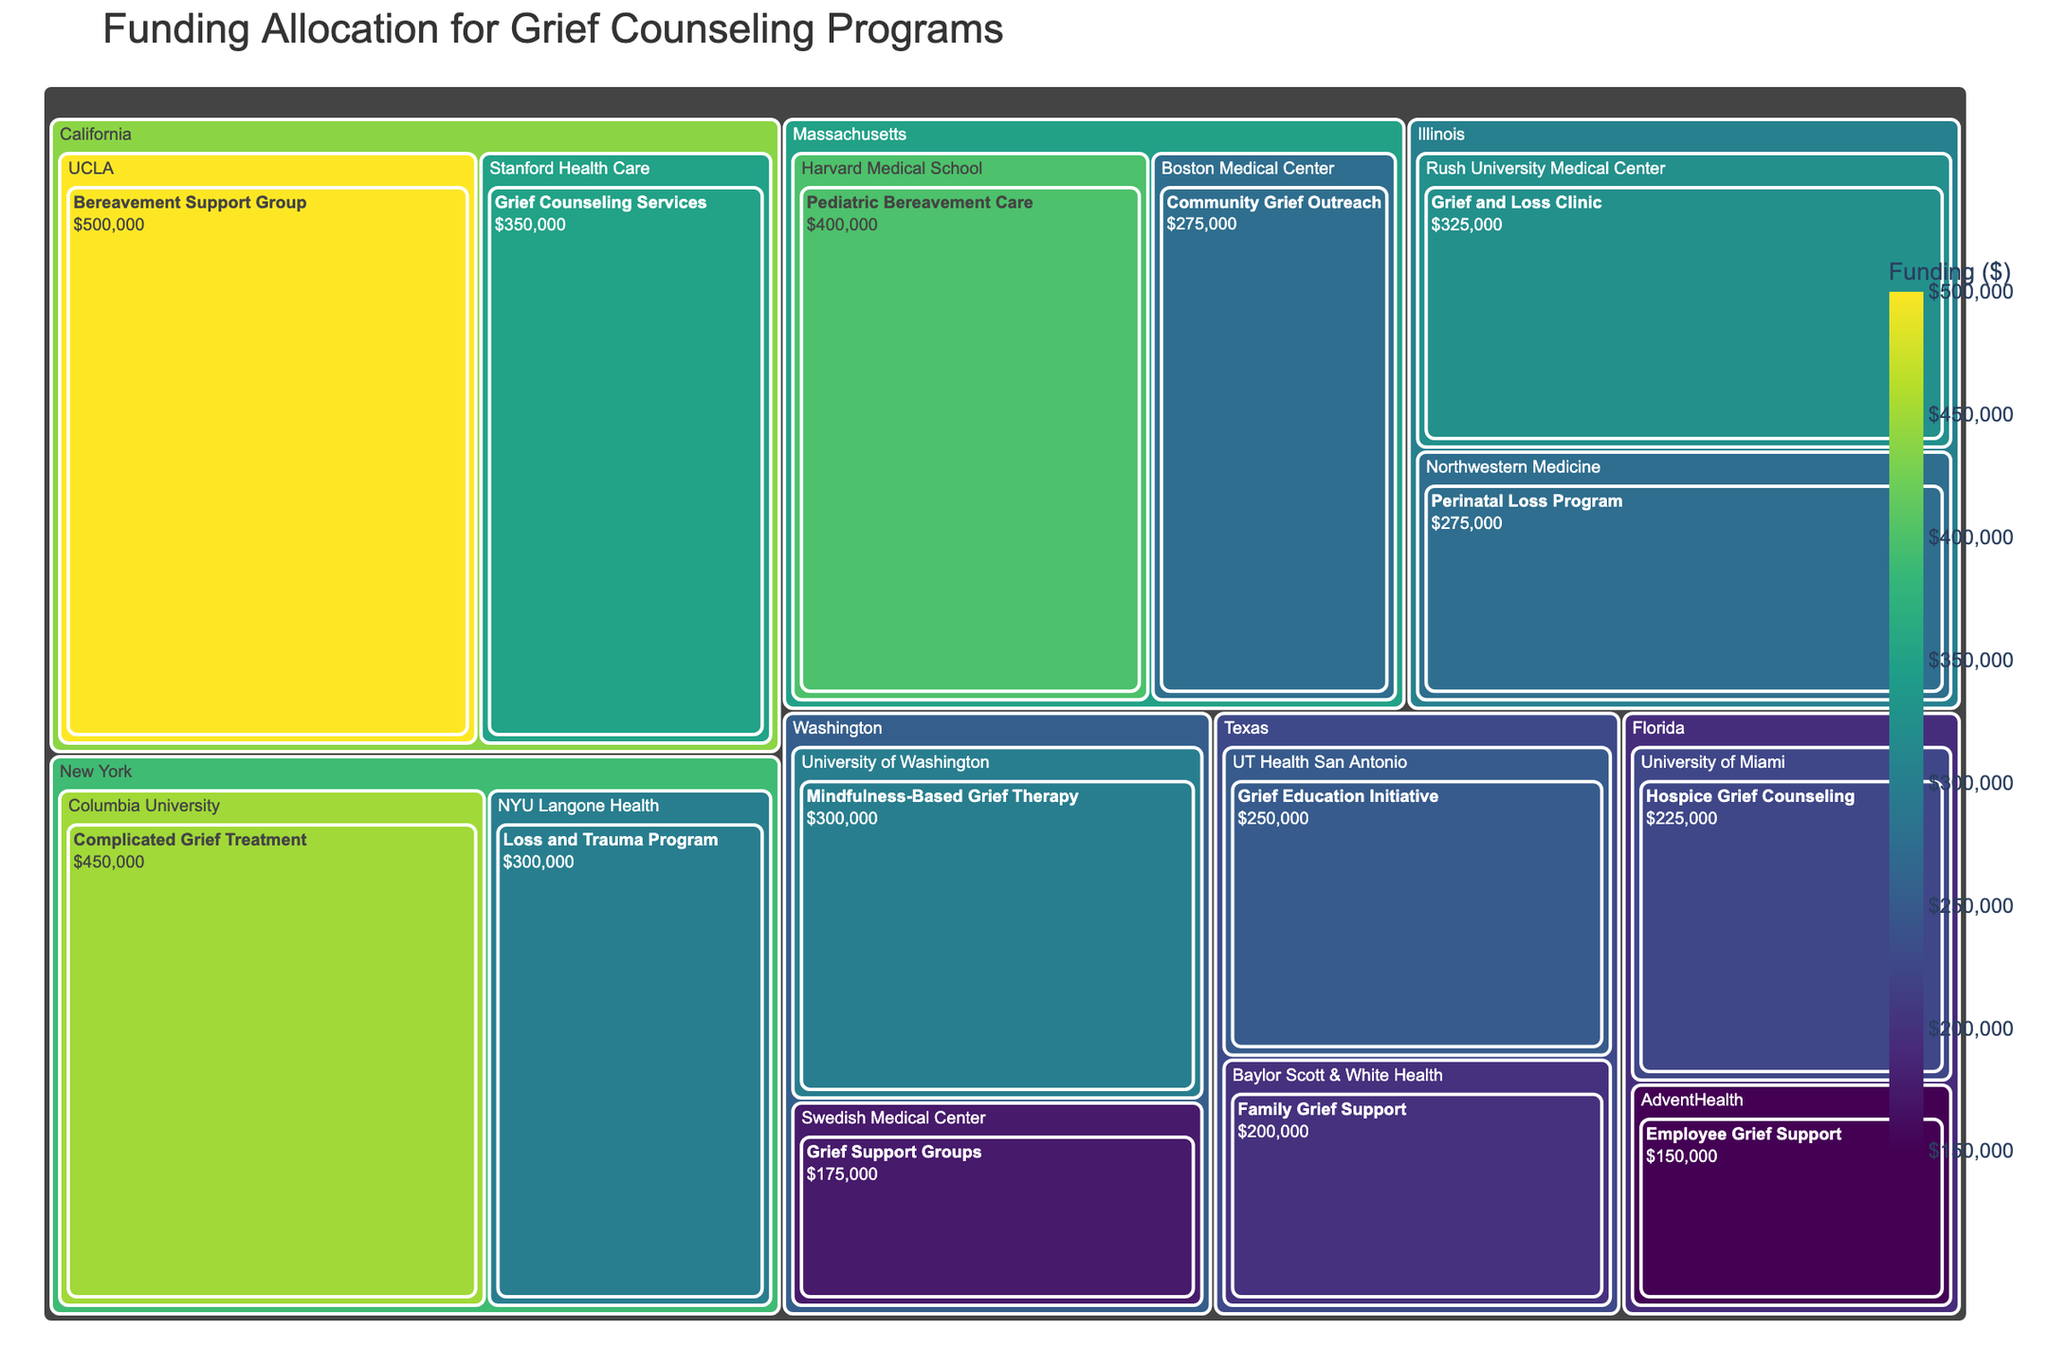How many institutions in California receive funding for grief counseling programs? To find this, look at the section of the treemap labeled "California" and count the institutions listed under it. There are 2 institutions: UCLA and Stanford Health Care.
Answer: 2 Which institution in Massachusetts received more funding for grief counseling programs? Identify the two institutions in Massachusetts, which are Harvard Medical School and Boston Medical Center. Compare the funding amounts: $400,000 for Harvard Medical School and $275,000 for Boston Medical Center. Harvard Medical School received more funding.
Answer: Harvard Medical School What is the total funding allocated for grief counseling programs in Texas? Sum the funding amounts provided to the institutions in Texas: UT Health San Antonio ($250,000) and Baylor Scott & White Health ($200,000). Therefore, the total funding is $250,000 + $200,000 = $450,000.
Answer: $450,000 Which state has the highest total funding for grief counseling programs? Sum the funding amounts for each state and compare them. California: $500,000 + $350,000 = $850,000, New York: $450,000 + $300,000 = $750,000, Texas: $450,000, Massachusetts: $400,000 + $275,000 = $675,000, Florida: $225,000 + $150,000 = $375,000, Illinois: $325,000 + $275,000 = $600,000, Washington: $300,000 + $175,000 = $475,000. California has the highest total funding.
Answer: California Which program received the least funding in the entire dataset? Scan through all the programs in the treemap sections and find the one with the smallest number. The program "Employee Grief Support" at AdventHealth in Florida has the least funding of $150,000.
Answer: Employee Grief Support What's the combined funding for grief counseling programs at institutions in Illinois and Washington? Sum the total funding for Illinois and Washington. Illinois: $325,000 + $275,000 = $600,000, Washington: $300,000 + $175,000 = $475,000. The combined funding is $600,000 + $475,000 = $1,075,000.
Answer: $1,075,000 Which program in New York received more funding: "Complicated Grief Treatment" or "Loss and Trauma Program"? Identify the funding amounts for both programs in New York: "Complicated Grief Treatment" at Columbia University ($450,000) and "Loss and Trauma Program" at NYU Langone Health ($300,000). "Complicated Grief Treatment" received more funding.
Answer: Complicated Grief Treatment What is the average funding allocated per institution in Florida? Identify the funding for both institutions in Florida: University of Miami ($225,000) and AdventHealth ($150,000). Sum these amounts and divide by 2. The total is $225,000 + $150,000 = $375,000. The average is $375,000 / 2 = $187,500.
Answer: $187,500 Across all states, how many different programs are funded for grief counseling? Count the number of unique programs listed under each institution across all states. There are 14 unique programs in total.
Answer: 14 